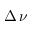Convert formula to latex. <formula><loc_0><loc_0><loc_500><loc_500>\Delta \, \nu</formula> 